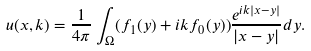Convert formula to latex. <formula><loc_0><loc_0><loc_500><loc_500>u ( x , k ) = \frac { 1 } { 4 \pi } \int _ { \Omega } ( f _ { 1 } ( y ) + i k f _ { 0 } ( y ) ) \frac { e ^ { i k | x - y | } } { | x - y | } d y .</formula> 